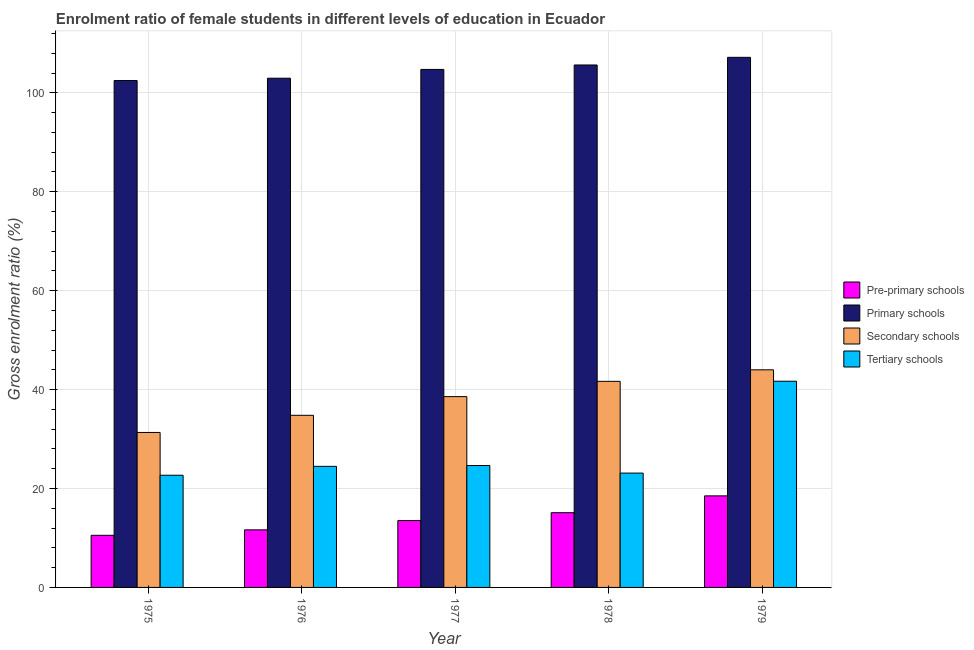Are the number of bars on each tick of the X-axis equal?
Keep it short and to the point. Yes. What is the label of the 2nd group of bars from the left?
Your response must be concise. 1976. What is the gross enrolment ratio(male) in primary schools in 1976?
Offer a terse response. 102.96. Across all years, what is the maximum gross enrolment ratio(male) in primary schools?
Provide a succinct answer. 107.18. Across all years, what is the minimum gross enrolment ratio(male) in pre-primary schools?
Provide a succinct answer. 10.54. In which year was the gross enrolment ratio(male) in primary schools maximum?
Your answer should be compact. 1979. In which year was the gross enrolment ratio(male) in pre-primary schools minimum?
Make the answer very short. 1975. What is the total gross enrolment ratio(male) in primary schools in the graph?
Give a very brief answer. 523.01. What is the difference between the gross enrolment ratio(male) in pre-primary schools in 1977 and that in 1979?
Make the answer very short. -4.99. What is the difference between the gross enrolment ratio(male) in primary schools in 1977 and the gross enrolment ratio(male) in pre-primary schools in 1978?
Ensure brevity in your answer.  -0.9. What is the average gross enrolment ratio(male) in primary schools per year?
Ensure brevity in your answer.  104.6. What is the ratio of the gross enrolment ratio(male) in tertiary schools in 1976 to that in 1978?
Offer a terse response. 1.06. What is the difference between the highest and the second highest gross enrolment ratio(male) in tertiary schools?
Keep it short and to the point. 17.04. What is the difference between the highest and the lowest gross enrolment ratio(male) in tertiary schools?
Offer a terse response. 19.01. Is the sum of the gross enrolment ratio(male) in pre-primary schools in 1975 and 1979 greater than the maximum gross enrolment ratio(male) in secondary schools across all years?
Your answer should be very brief. Yes. What does the 2nd bar from the left in 1979 represents?
Provide a short and direct response. Primary schools. What does the 2nd bar from the right in 1976 represents?
Your answer should be very brief. Secondary schools. Is it the case that in every year, the sum of the gross enrolment ratio(male) in pre-primary schools and gross enrolment ratio(male) in primary schools is greater than the gross enrolment ratio(male) in secondary schools?
Your answer should be very brief. Yes. Are all the bars in the graph horizontal?
Make the answer very short. No. How many years are there in the graph?
Your answer should be compact. 5. What is the difference between two consecutive major ticks on the Y-axis?
Make the answer very short. 20. Does the graph contain any zero values?
Give a very brief answer. No. What is the title of the graph?
Give a very brief answer. Enrolment ratio of female students in different levels of education in Ecuador. Does "Taxes on goods and services" appear as one of the legend labels in the graph?
Keep it short and to the point. No. What is the label or title of the X-axis?
Make the answer very short. Year. What is the label or title of the Y-axis?
Your answer should be very brief. Gross enrolment ratio (%). What is the Gross enrolment ratio (%) of Pre-primary schools in 1975?
Ensure brevity in your answer.  10.54. What is the Gross enrolment ratio (%) of Primary schools in 1975?
Provide a short and direct response. 102.49. What is the Gross enrolment ratio (%) of Secondary schools in 1975?
Offer a very short reply. 31.33. What is the Gross enrolment ratio (%) of Tertiary schools in 1975?
Your response must be concise. 22.68. What is the Gross enrolment ratio (%) of Pre-primary schools in 1976?
Keep it short and to the point. 11.64. What is the Gross enrolment ratio (%) of Primary schools in 1976?
Make the answer very short. 102.96. What is the Gross enrolment ratio (%) of Secondary schools in 1976?
Make the answer very short. 34.8. What is the Gross enrolment ratio (%) of Tertiary schools in 1976?
Keep it short and to the point. 24.48. What is the Gross enrolment ratio (%) in Pre-primary schools in 1977?
Offer a terse response. 13.52. What is the Gross enrolment ratio (%) in Primary schools in 1977?
Offer a terse response. 104.74. What is the Gross enrolment ratio (%) of Secondary schools in 1977?
Your response must be concise. 38.58. What is the Gross enrolment ratio (%) in Tertiary schools in 1977?
Offer a terse response. 24.65. What is the Gross enrolment ratio (%) of Pre-primary schools in 1978?
Provide a short and direct response. 15.11. What is the Gross enrolment ratio (%) of Primary schools in 1978?
Make the answer very short. 105.64. What is the Gross enrolment ratio (%) in Secondary schools in 1978?
Your answer should be compact. 41.67. What is the Gross enrolment ratio (%) in Tertiary schools in 1978?
Make the answer very short. 23.12. What is the Gross enrolment ratio (%) of Pre-primary schools in 1979?
Keep it short and to the point. 18.51. What is the Gross enrolment ratio (%) in Primary schools in 1979?
Your answer should be very brief. 107.18. What is the Gross enrolment ratio (%) in Secondary schools in 1979?
Your answer should be very brief. 44. What is the Gross enrolment ratio (%) in Tertiary schools in 1979?
Ensure brevity in your answer.  41.69. Across all years, what is the maximum Gross enrolment ratio (%) of Pre-primary schools?
Provide a succinct answer. 18.51. Across all years, what is the maximum Gross enrolment ratio (%) in Primary schools?
Offer a very short reply. 107.18. Across all years, what is the maximum Gross enrolment ratio (%) of Secondary schools?
Offer a very short reply. 44. Across all years, what is the maximum Gross enrolment ratio (%) in Tertiary schools?
Provide a succinct answer. 41.69. Across all years, what is the minimum Gross enrolment ratio (%) in Pre-primary schools?
Ensure brevity in your answer.  10.54. Across all years, what is the minimum Gross enrolment ratio (%) of Primary schools?
Provide a succinct answer. 102.49. Across all years, what is the minimum Gross enrolment ratio (%) in Secondary schools?
Ensure brevity in your answer.  31.33. Across all years, what is the minimum Gross enrolment ratio (%) in Tertiary schools?
Make the answer very short. 22.68. What is the total Gross enrolment ratio (%) of Pre-primary schools in the graph?
Offer a very short reply. 69.32. What is the total Gross enrolment ratio (%) of Primary schools in the graph?
Your answer should be very brief. 523.01. What is the total Gross enrolment ratio (%) of Secondary schools in the graph?
Keep it short and to the point. 190.38. What is the total Gross enrolment ratio (%) of Tertiary schools in the graph?
Your response must be concise. 136.63. What is the difference between the Gross enrolment ratio (%) in Pre-primary schools in 1975 and that in 1976?
Keep it short and to the point. -1.1. What is the difference between the Gross enrolment ratio (%) in Primary schools in 1975 and that in 1976?
Offer a terse response. -0.47. What is the difference between the Gross enrolment ratio (%) in Secondary schools in 1975 and that in 1976?
Provide a succinct answer. -3.47. What is the difference between the Gross enrolment ratio (%) in Tertiary schools in 1975 and that in 1976?
Offer a very short reply. -1.8. What is the difference between the Gross enrolment ratio (%) of Pre-primary schools in 1975 and that in 1977?
Provide a succinct answer. -2.98. What is the difference between the Gross enrolment ratio (%) of Primary schools in 1975 and that in 1977?
Ensure brevity in your answer.  -2.25. What is the difference between the Gross enrolment ratio (%) of Secondary schools in 1975 and that in 1977?
Offer a terse response. -7.25. What is the difference between the Gross enrolment ratio (%) in Tertiary schools in 1975 and that in 1977?
Ensure brevity in your answer.  -1.97. What is the difference between the Gross enrolment ratio (%) in Pre-primary schools in 1975 and that in 1978?
Your answer should be compact. -4.57. What is the difference between the Gross enrolment ratio (%) of Primary schools in 1975 and that in 1978?
Your response must be concise. -3.15. What is the difference between the Gross enrolment ratio (%) in Secondary schools in 1975 and that in 1978?
Provide a short and direct response. -10.34. What is the difference between the Gross enrolment ratio (%) of Tertiary schools in 1975 and that in 1978?
Your response must be concise. -0.44. What is the difference between the Gross enrolment ratio (%) of Pre-primary schools in 1975 and that in 1979?
Make the answer very short. -7.97. What is the difference between the Gross enrolment ratio (%) in Primary schools in 1975 and that in 1979?
Keep it short and to the point. -4.7. What is the difference between the Gross enrolment ratio (%) of Secondary schools in 1975 and that in 1979?
Provide a short and direct response. -12.66. What is the difference between the Gross enrolment ratio (%) of Tertiary schools in 1975 and that in 1979?
Give a very brief answer. -19.01. What is the difference between the Gross enrolment ratio (%) in Pre-primary schools in 1976 and that in 1977?
Make the answer very short. -1.88. What is the difference between the Gross enrolment ratio (%) in Primary schools in 1976 and that in 1977?
Your answer should be compact. -1.78. What is the difference between the Gross enrolment ratio (%) of Secondary schools in 1976 and that in 1977?
Your response must be concise. -3.78. What is the difference between the Gross enrolment ratio (%) in Tertiary schools in 1976 and that in 1977?
Offer a terse response. -0.17. What is the difference between the Gross enrolment ratio (%) in Pre-primary schools in 1976 and that in 1978?
Your answer should be compact. -3.47. What is the difference between the Gross enrolment ratio (%) in Primary schools in 1976 and that in 1978?
Keep it short and to the point. -2.68. What is the difference between the Gross enrolment ratio (%) in Secondary schools in 1976 and that in 1978?
Your response must be concise. -6.87. What is the difference between the Gross enrolment ratio (%) in Tertiary schools in 1976 and that in 1978?
Offer a terse response. 1.36. What is the difference between the Gross enrolment ratio (%) in Pre-primary schools in 1976 and that in 1979?
Your answer should be compact. -6.87. What is the difference between the Gross enrolment ratio (%) of Primary schools in 1976 and that in 1979?
Make the answer very short. -4.22. What is the difference between the Gross enrolment ratio (%) of Secondary schools in 1976 and that in 1979?
Your answer should be compact. -9.2. What is the difference between the Gross enrolment ratio (%) of Tertiary schools in 1976 and that in 1979?
Make the answer very short. -17.21. What is the difference between the Gross enrolment ratio (%) of Pre-primary schools in 1977 and that in 1978?
Ensure brevity in your answer.  -1.59. What is the difference between the Gross enrolment ratio (%) of Primary schools in 1977 and that in 1978?
Offer a terse response. -0.9. What is the difference between the Gross enrolment ratio (%) of Secondary schools in 1977 and that in 1978?
Your response must be concise. -3.09. What is the difference between the Gross enrolment ratio (%) in Tertiary schools in 1977 and that in 1978?
Keep it short and to the point. 1.53. What is the difference between the Gross enrolment ratio (%) of Pre-primary schools in 1977 and that in 1979?
Offer a terse response. -4.99. What is the difference between the Gross enrolment ratio (%) in Primary schools in 1977 and that in 1979?
Provide a succinct answer. -2.45. What is the difference between the Gross enrolment ratio (%) in Secondary schools in 1977 and that in 1979?
Provide a short and direct response. -5.42. What is the difference between the Gross enrolment ratio (%) in Tertiary schools in 1977 and that in 1979?
Keep it short and to the point. -17.04. What is the difference between the Gross enrolment ratio (%) in Pre-primary schools in 1978 and that in 1979?
Your answer should be compact. -3.4. What is the difference between the Gross enrolment ratio (%) in Primary schools in 1978 and that in 1979?
Your response must be concise. -1.54. What is the difference between the Gross enrolment ratio (%) of Secondary schools in 1978 and that in 1979?
Your answer should be compact. -2.33. What is the difference between the Gross enrolment ratio (%) in Tertiary schools in 1978 and that in 1979?
Your answer should be very brief. -18.57. What is the difference between the Gross enrolment ratio (%) of Pre-primary schools in 1975 and the Gross enrolment ratio (%) of Primary schools in 1976?
Keep it short and to the point. -92.42. What is the difference between the Gross enrolment ratio (%) of Pre-primary schools in 1975 and the Gross enrolment ratio (%) of Secondary schools in 1976?
Offer a very short reply. -24.26. What is the difference between the Gross enrolment ratio (%) in Pre-primary schools in 1975 and the Gross enrolment ratio (%) in Tertiary schools in 1976?
Offer a terse response. -13.94. What is the difference between the Gross enrolment ratio (%) of Primary schools in 1975 and the Gross enrolment ratio (%) of Secondary schools in 1976?
Your response must be concise. 67.68. What is the difference between the Gross enrolment ratio (%) in Primary schools in 1975 and the Gross enrolment ratio (%) in Tertiary schools in 1976?
Offer a very short reply. 78.01. What is the difference between the Gross enrolment ratio (%) in Secondary schools in 1975 and the Gross enrolment ratio (%) in Tertiary schools in 1976?
Make the answer very short. 6.85. What is the difference between the Gross enrolment ratio (%) in Pre-primary schools in 1975 and the Gross enrolment ratio (%) in Primary schools in 1977?
Offer a terse response. -94.2. What is the difference between the Gross enrolment ratio (%) of Pre-primary schools in 1975 and the Gross enrolment ratio (%) of Secondary schools in 1977?
Provide a succinct answer. -28.04. What is the difference between the Gross enrolment ratio (%) in Pre-primary schools in 1975 and the Gross enrolment ratio (%) in Tertiary schools in 1977?
Provide a succinct answer. -14.11. What is the difference between the Gross enrolment ratio (%) of Primary schools in 1975 and the Gross enrolment ratio (%) of Secondary schools in 1977?
Offer a very short reply. 63.91. What is the difference between the Gross enrolment ratio (%) of Primary schools in 1975 and the Gross enrolment ratio (%) of Tertiary schools in 1977?
Your answer should be compact. 77.84. What is the difference between the Gross enrolment ratio (%) of Secondary schools in 1975 and the Gross enrolment ratio (%) of Tertiary schools in 1977?
Your answer should be very brief. 6.68. What is the difference between the Gross enrolment ratio (%) of Pre-primary schools in 1975 and the Gross enrolment ratio (%) of Primary schools in 1978?
Offer a very short reply. -95.1. What is the difference between the Gross enrolment ratio (%) of Pre-primary schools in 1975 and the Gross enrolment ratio (%) of Secondary schools in 1978?
Provide a short and direct response. -31.13. What is the difference between the Gross enrolment ratio (%) in Pre-primary schools in 1975 and the Gross enrolment ratio (%) in Tertiary schools in 1978?
Your answer should be very brief. -12.58. What is the difference between the Gross enrolment ratio (%) in Primary schools in 1975 and the Gross enrolment ratio (%) in Secondary schools in 1978?
Provide a succinct answer. 60.82. What is the difference between the Gross enrolment ratio (%) in Primary schools in 1975 and the Gross enrolment ratio (%) in Tertiary schools in 1978?
Your answer should be very brief. 79.37. What is the difference between the Gross enrolment ratio (%) in Secondary schools in 1975 and the Gross enrolment ratio (%) in Tertiary schools in 1978?
Your answer should be very brief. 8.21. What is the difference between the Gross enrolment ratio (%) of Pre-primary schools in 1975 and the Gross enrolment ratio (%) of Primary schools in 1979?
Offer a very short reply. -96.64. What is the difference between the Gross enrolment ratio (%) in Pre-primary schools in 1975 and the Gross enrolment ratio (%) in Secondary schools in 1979?
Keep it short and to the point. -33.46. What is the difference between the Gross enrolment ratio (%) in Pre-primary schools in 1975 and the Gross enrolment ratio (%) in Tertiary schools in 1979?
Keep it short and to the point. -31.15. What is the difference between the Gross enrolment ratio (%) of Primary schools in 1975 and the Gross enrolment ratio (%) of Secondary schools in 1979?
Make the answer very short. 58.49. What is the difference between the Gross enrolment ratio (%) in Primary schools in 1975 and the Gross enrolment ratio (%) in Tertiary schools in 1979?
Your answer should be compact. 60.79. What is the difference between the Gross enrolment ratio (%) of Secondary schools in 1975 and the Gross enrolment ratio (%) of Tertiary schools in 1979?
Your answer should be compact. -10.36. What is the difference between the Gross enrolment ratio (%) in Pre-primary schools in 1976 and the Gross enrolment ratio (%) in Primary schools in 1977?
Ensure brevity in your answer.  -93.1. What is the difference between the Gross enrolment ratio (%) of Pre-primary schools in 1976 and the Gross enrolment ratio (%) of Secondary schools in 1977?
Provide a succinct answer. -26.94. What is the difference between the Gross enrolment ratio (%) of Pre-primary schools in 1976 and the Gross enrolment ratio (%) of Tertiary schools in 1977?
Your answer should be compact. -13.01. What is the difference between the Gross enrolment ratio (%) in Primary schools in 1976 and the Gross enrolment ratio (%) in Secondary schools in 1977?
Your response must be concise. 64.38. What is the difference between the Gross enrolment ratio (%) of Primary schools in 1976 and the Gross enrolment ratio (%) of Tertiary schools in 1977?
Your answer should be compact. 78.31. What is the difference between the Gross enrolment ratio (%) in Secondary schools in 1976 and the Gross enrolment ratio (%) in Tertiary schools in 1977?
Make the answer very short. 10.15. What is the difference between the Gross enrolment ratio (%) in Pre-primary schools in 1976 and the Gross enrolment ratio (%) in Primary schools in 1978?
Your response must be concise. -94. What is the difference between the Gross enrolment ratio (%) of Pre-primary schools in 1976 and the Gross enrolment ratio (%) of Secondary schools in 1978?
Ensure brevity in your answer.  -30.03. What is the difference between the Gross enrolment ratio (%) in Pre-primary schools in 1976 and the Gross enrolment ratio (%) in Tertiary schools in 1978?
Your answer should be compact. -11.48. What is the difference between the Gross enrolment ratio (%) of Primary schools in 1976 and the Gross enrolment ratio (%) of Secondary schools in 1978?
Provide a succinct answer. 61.29. What is the difference between the Gross enrolment ratio (%) of Primary schools in 1976 and the Gross enrolment ratio (%) of Tertiary schools in 1978?
Give a very brief answer. 79.84. What is the difference between the Gross enrolment ratio (%) in Secondary schools in 1976 and the Gross enrolment ratio (%) in Tertiary schools in 1978?
Your response must be concise. 11.68. What is the difference between the Gross enrolment ratio (%) in Pre-primary schools in 1976 and the Gross enrolment ratio (%) in Primary schools in 1979?
Provide a succinct answer. -95.54. What is the difference between the Gross enrolment ratio (%) of Pre-primary schools in 1976 and the Gross enrolment ratio (%) of Secondary schools in 1979?
Make the answer very short. -32.36. What is the difference between the Gross enrolment ratio (%) of Pre-primary schools in 1976 and the Gross enrolment ratio (%) of Tertiary schools in 1979?
Ensure brevity in your answer.  -30.05. What is the difference between the Gross enrolment ratio (%) of Primary schools in 1976 and the Gross enrolment ratio (%) of Secondary schools in 1979?
Make the answer very short. 58.96. What is the difference between the Gross enrolment ratio (%) of Primary schools in 1976 and the Gross enrolment ratio (%) of Tertiary schools in 1979?
Offer a very short reply. 61.27. What is the difference between the Gross enrolment ratio (%) in Secondary schools in 1976 and the Gross enrolment ratio (%) in Tertiary schools in 1979?
Offer a very short reply. -6.89. What is the difference between the Gross enrolment ratio (%) in Pre-primary schools in 1977 and the Gross enrolment ratio (%) in Primary schools in 1978?
Provide a succinct answer. -92.12. What is the difference between the Gross enrolment ratio (%) of Pre-primary schools in 1977 and the Gross enrolment ratio (%) of Secondary schools in 1978?
Make the answer very short. -28.15. What is the difference between the Gross enrolment ratio (%) of Pre-primary schools in 1977 and the Gross enrolment ratio (%) of Tertiary schools in 1978?
Provide a succinct answer. -9.6. What is the difference between the Gross enrolment ratio (%) in Primary schools in 1977 and the Gross enrolment ratio (%) in Secondary schools in 1978?
Your answer should be compact. 63.07. What is the difference between the Gross enrolment ratio (%) in Primary schools in 1977 and the Gross enrolment ratio (%) in Tertiary schools in 1978?
Provide a succinct answer. 81.62. What is the difference between the Gross enrolment ratio (%) of Secondary schools in 1977 and the Gross enrolment ratio (%) of Tertiary schools in 1978?
Your answer should be very brief. 15.46. What is the difference between the Gross enrolment ratio (%) of Pre-primary schools in 1977 and the Gross enrolment ratio (%) of Primary schools in 1979?
Your response must be concise. -93.66. What is the difference between the Gross enrolment ratio (%) of Pre-primary schools in 1977 and the Gross enrolment ratio (%) of Secondary schools in 1979?
Your response must be concise. -30.48. What is the difference between the Gross enrolment ratio (%) in Pre-primary schools in 1977 and the Gross enrolment ratio (%) in Tertiary schools in 1979?
Offer a very short reply. -28.17. What is the difference between the Gross enrolment ratio (%) in Primary schools in 1977 and the Gross enrolment ratio (%) in Secondary schools in 1979?
Your answer should be very brief. 60.74. What is the difference between the Gross enrolment ratio (%) of Primary schools in 1977 and the Gross enrolment ratio (%) of Tertiary schools in 1979?
Give a very brief answer. 63.04. What is the difference between the Gross enrolment ratio (%) of Secondary schools in 1977 and the Gross enrolment ratio (%) of Tertiary schools in 1979?
Your answer should be compact. -3.11. What is the difference between the Gross enrolment ratio (%) in Pre-primary schools in 1978 and the Gross enrolment ratio (%) in Primary schools in 1979?
Ensure brevity in your answer.  -92.07. What is the difference between the Gross enrolment ratio (%) of Pre-primary schools in 1978 and the Gross enrolment ratio (%) of Secondary schools in 1979?
Make the answer very short. -28.89. What is the difference between the Gross enrolment ratio (%) of Pre-primary schools in 1978 and the Gross enrolment ratio (%) of Tertiary schools in 1979?
Offer a terse response. -26.58. What is the difference between the Gross enrolment ratio (%) of Primary schools in 1978 and the Gross enrolment ratio (%) of Secondary schools in 1979?
Keep it short and to the point. 61.64. What is the difference between the Gross enrolment ratio (%) of Primary schools in 1978 and the Gross enrolment ratio (%) of Tertiary schools in 1979?
Keep it short and to the point. 63.94. What is the difference between the Gross enrolment ratio (%) in Secondary schools in 1978 and the Gross enrolment ratio (%) in Tertiary schools in 1979?
Make the answer very short. -0.02. What is the average Gross enrolment ratio (%) of Pre-primary schools per year?
Make the answer very short. 13.86. What is the average Gross enrolment ratio (%) of Primary schools per year?
Keep it short and to the point. 104.6. What is the average Gross enrolment ratio (%) of Secondary schools per year?
Your response must be concise. 38.08. What is the average Gross enrolment ratio (%) of Tertiary schools per year?
Ensure brevity in your answer.  27.33. In the year 1975, what is the difference between the Gross enrolment ratio (%) of Pre-primary schools and Gross enrolment ratio (%) of Primary schools?
Your answer should be compact. -91.95. In the year 1975, what is the difference between the Gross enrolment ratio (%) of Pre-primary schools and Gross enrolment ratio (%) of Secondary schools?
Your response must be concise. -20.79. In the year 1975, what is the difference between the Gross enrolment ratio (%) of Pre-primary schools and Gross enrolment ratio (%) of Tertiary schools?
Ensure brevity in your answer.  -12.14. In the year 1975, what is the difference between the Gross enrolment ratio (%) of Primary schools and Gross enrolment ratio (%) of Secondary schools?
Keep it short and to the point. 71.15. In the year 1975, what is the difference between the Gross enrolment ratio (%) of Primary schools and Gross enrolment ratio (%) of Tertiary schools?
Ensure brevity in your answer.  79.8. In the year 1975, what is the difference between the Gross enrolment ratio (%) in Secondary schools and Gross enrolment ratio (%) in Tertiary schools?
Ensure brevity in your answer.  8.65. In the year 1976, what is the difference between the Gross enrolment ratio (%) in Pre-primary schools and Gross enrolment ratio (%) in Primary schools?
Your response must be concise. -91.32. In the year 1976, what is the difference between the Gross enrolment ratio (%) of Pre-primary schools and Gross enrolment ratio (%) of Secondary schools?
Keep it short and to the point. -23.16. In the year 1976, what is the difference between the Gross enrolment ratio (%) of Pre-primary schools and Gross enrolment ratio (%) of Tertiary schools?
Offer a very short reply. -12.84. In the year 1976, what is the difference between the Gross enrolment ratio (%) in Primary schools and Gross enrolment ratio (%) in Secondary schools?
Your answer should be very brief. 68.16. In the year 1976, what is the difference between the Gross enrolment ratio (%) in Primary schools and Gross enrolment ratio (%) in Tertiary schools?
Make the answer very short. 78.48. In the year 1976, what is the difference between the Gross enrolment ratio (%) in Secondary schools and Gross enrolment ratio (%) in Tertiary schools?
Give a very brief answer. 10.32. In the year 1977, what is the difference between the Gross enrolment ratio (%) of Pre-primary schools and Gross enrolment ratio (%) of Primary schools?
Your response must be concise. -91.21. In the year 1977, what is the difference between the Gross enrolment ratio (%) of Pre-primary schools and Gross enrolment ratio (%) of Secondary schools?
Offer a terse response. -25.06. In the year 1977, what is the difference between the Gross enrolment ratio (%) of Pre-primary schools and Gross enrolment ratio (%) of Tertiary schools?
Ensure brevity in your answer.  -11.13. In the year 1977, what is the difference between the Gross enrolment ratio (%) of Primary schools and Gross enrolment ratio (%) of Secondary schools?
Make the answer very short. 66.16. In the year 1977, what is the difference between the Gross enrolment ratio (%) in Primary schools and Gross enrolment ratio (%) in Tertiary schools?
Ensure brevity in your answer.  80.09. In the year 1977, what is the difference between the Gross enrolment ratio (%) in Secondary schools and Gross enrolment ratio (%) in Tertiary schools?
Your response must be concise. 13.93. In the year 1978, what is the difference between the Gross enrolment ratio (%) of Pre-primary schools and Gross enrolment ratio (%) of Primary schools?
Offer a terse response. -90.53. In the year 1978, what is the difference between the Gross enrolment ratio (%) of Pre-primary schools and Gross enrolment ratio (%) of Secondary schools?
Ensure brevity in your answer.  -26.56. In the year 1978, what is the difference between the Gross enrolment ratio (%) in Pre-primary schools and Gross enrolment ratio (%) in Tertiary schools?
Your answer should be compact. -8.01. In the year 1978, what is the difference between the Gross enrolment ratio (%) in Primary schools and Gross enrolment ratio (%) in Secondary schools?
Your answer should be very brief. 63.97. In the year 1978, what is the difference between the Gross enrolment ratio (%) in Primary schools and Gross enrolment ratio (%) in Tertiary schools?
Ensure brevity in your answer.  82.52. In the year 1978, what is the difference between the Gross enrolment ratio (%) of Secondary schools and Gross enrolment ratio (%) of Tertiary schools?
Offer a terse response. 18.55. In the year 1979, what is the difference between the Gross enrolment ratio (%) in Pre-primary schools and Gross enrolment ratio (%) in Primary schools?
Ensure brevity in your answer.  -88.67. In the year 1979, what is the difference between the Gross enrolment ratio (%) in Pre-primary schools and Gross enrolment ratio (%) in Secondary schools?
Keep it short and to the point. -25.49. In the year 1979, what is the difference between the Gross enrolment ratio (%) of Pre-primary schools and Gross enrolment ratio (%) of Tertiary schools?
Provide a succinct answer. -23.18. In the year 1979, what is the difference between the Gross enrolment ratio (%) of Primary schools and Gross enrolment ratio (%) of Secondary schools?
Your response must be concise. 63.19. In the year 1979, what is the difference between the Gross enrolment ratio (%) in Primary schools and Gross enrolment ratio (%) in Tertiary schools?
Give a very brief answer. 65.49. In the year 1979, what is the difference between the Gross enrolment ratio (%) of Secondary schools and Gross enrolment ratio (%) of Tertiary schools?
Offer a terse response. 2.3. What is the ratio of the Gross enrolment ratio (%) in Pre-primary schools in 1975 to that in 1976?
Give a very brief answer. 0.91. What is the ratio of the Gross enrolment ratio (%) in Primary schools in 1975 to that in 1976?
Provide a short and direct response. 1. What is the ratio of the Gross enrolment ratio (%) in Secondary schools in 1975 to that in 1976?
Ensure brevity in your answer.  0.9. What is the ratio of the Gross enrolment ratio (%) of Tertiary schools in 1975 to that in 1976?
Keep it short and to the point. 0.93. What is the ratio of the Gross enrolment ratio (%) of Pre-primary schools in 1975 to that in 1977?
Keep it short and to the point. 0.78. What is the ratio of the Gross enrolment ratio (%) in Primary schools in 1975 to that in 1977?
Offer a very short reply. 0.98. What is the ratio of the Gross enrolment ratio (%) of Secondary schools in 1975 to that in 1977?
Provide a succinct answer. 0.81. What is the ratio of the Gross enrolment ratio (%) in Tertiary schools in 1975 to that in 1977?
Offer a very short reply. 0.92. What is the ratio of the Gross enrolment ratio (%) in Pre-primary schools in 1975 to that in 1978?
Provide a short and direct response. 0.7. What is the ratio of the Gross enrolment ratio (%) in Primary schools in 1975 to that in 1978?
Your answer should be compact. 0.97. What is the ratio of the Gross enrolment ratio (%) of Secondary schools in 1975 to that in 1978?
Your answer should be very brief. 0.75. What is the ratio of the Gross enrolment ratio (%) in Tertiary schools in 1975 to that in 1978?
Give a very brief answer. 0.98. What is the ratio of the Gross enrolment ratio (%) in Pre-primary schools in 1975 to that in 1979?
Keep it short and to the point. 0.57. What is the ratio of the Gross enrolment ratio (%) in Primary schools in 1975 to that in 1979?
Make the answer very short. 0.96. What is the ratio of the Gross enrolment ratio (%) of Secondary schools in 1975 to that in 1979?
Your answer should be compact. 0.71. What is the ratio of the Gross enrolment ratio (%) in Tertiary schools in 1975 to that in 1979?
Keep it short and to the point. 0.54. What is the ratio of the Gross enrolment ratio (%) of Pre-primary schools in 1976 to that in 1977?
Your answer should be very brief. 0.86. What is the ratio of the Gross enrolment ratio (%) in Secondary schools in 1976 to that in 1977?
Make the answer very short. 0.9. What is the ratio of the Gross enrolment ratio (%) of Pre-primary schools in 1976 to that in 1978?
Your answer should be very brief. 0.77. What is the ratio of the Gross enrolment ratio (%) in Primary schools in 1976 to that in 1978?
Ensure brevity in your answer.  0.97. What is the ratio of the Gross enrolment ratio (%) in Secondary schools in 1976 to that in 1978?
Give a very brief answer. 0.84. What is the ratio of the Gross enrolment ratio (%) in Tertiary schools in 1976 to that in 1978?
Make the answer very short. 1.06. What is the ratio of the Gross enrolment ratio (%) of Pre-primary schools in 1976 to that in 1979?
Your answer should be very brief. 0.63. What is the ratio of the Gross enrolment ratio (%) in Primary schools in 1976 to that in 1979?
Provide a short and direct response. 0.96. What is the ratio of the Gross enrolment ratio (%) in Secondary schools in 1976 to that in 1979?
Offer a terse response. 0.79. What is the ratio of the Gross enrolment ratio (%) in Tertiary schools in 1976 to that in 1979?
Make the answer very short. 0.59. What is the ratio of the Gross enrolment ratio (%) of Pre-primary schools in 1977 to that in 1978?
Keep it short and to the point. 0.89. What is the ratio of the Gross enrolment ratio (%) in Secondary schools in 1977 to that in 1978?
Provide a succinct answer. 0.93. What is the ratio of the Gross enrolment ratio (%) of Tertiary schools in 1977 to that in 1978?
Give a very brief answer. 1.07. What is the ratio of the Gross enrolment ratio (%) of Pre-primary schools in 1977 to that in 1979?
Provide a succinct answer. 0.73. What is the ratio of the Gross enrolment ratio (%) of Primary schools in 1977 to that in 1979?
Offer a terse response. 0.98. What is the ratio of the Gross enrolment ratio (%) of Secondary schools in 1977 to that in 1979?
Give a very brief answer. 0.88. What is the ratio of the Gross enrolment ratio (%) of Tertiary schools in 1977 to that in 1979?
Offer a very short reply. 0.59. What is the ratio of the Gross enrolment ratio (%) in Pre-primary schools in 1978 to that in 1979?
Keep it short and to the point. 0.82. What is the ratio of the Gross enrolment ratio (%) of Primary schools in 1978 to that in 1979?
Ensure brevity in your answer.  0.99. What is the ratio of the Gross enrolment ratio (%) of Secondary schools in 1978 to that in 1979?
Provide a succinct answer. 0.95. What is the ratio of the Gross enrolment ratio (%) in Tertiary schools in 1978 to that in 1979?
Your answer should be very brief. 0.55. What is the difference between the highest and the second highest Gross enrolment ratio (%) of Pre-primary schools?
Ensure brevity in your answer.  3.4. What is the difference between the highest and the second highest Gross enrolment ratio (%) of Primary schools?
Give a very brief answer. 1.54. What is the difference between the highest and the second highest Gross enrolment ratio (%) in Secondary schools?
Provide a short and direct response. 2.33. What is the difference between the highest and the second highest Gross enrolment ratio (%) in Tertiary schools?
Your response must be concise. 17.04. What is the difference between the highest and the lowest Gross enrolment ratio (%) of Pre-primary schools?
Keep it short and to the point. 7.97. What is the difference between the highest and the lowest Gross enrolment ratio (%) of Primary schools?
Ensure brevity in your answer.  4.7. What is the difference between the highest and the lowest Gross enrolment ratio (%) of Secondary schools?
Your answer should be very brief. 12.66. What is the difference between the highest and the lowest Gross enrolment ratio (%) of Tertiary schools?
Provide a short and direct response. 19.01. 